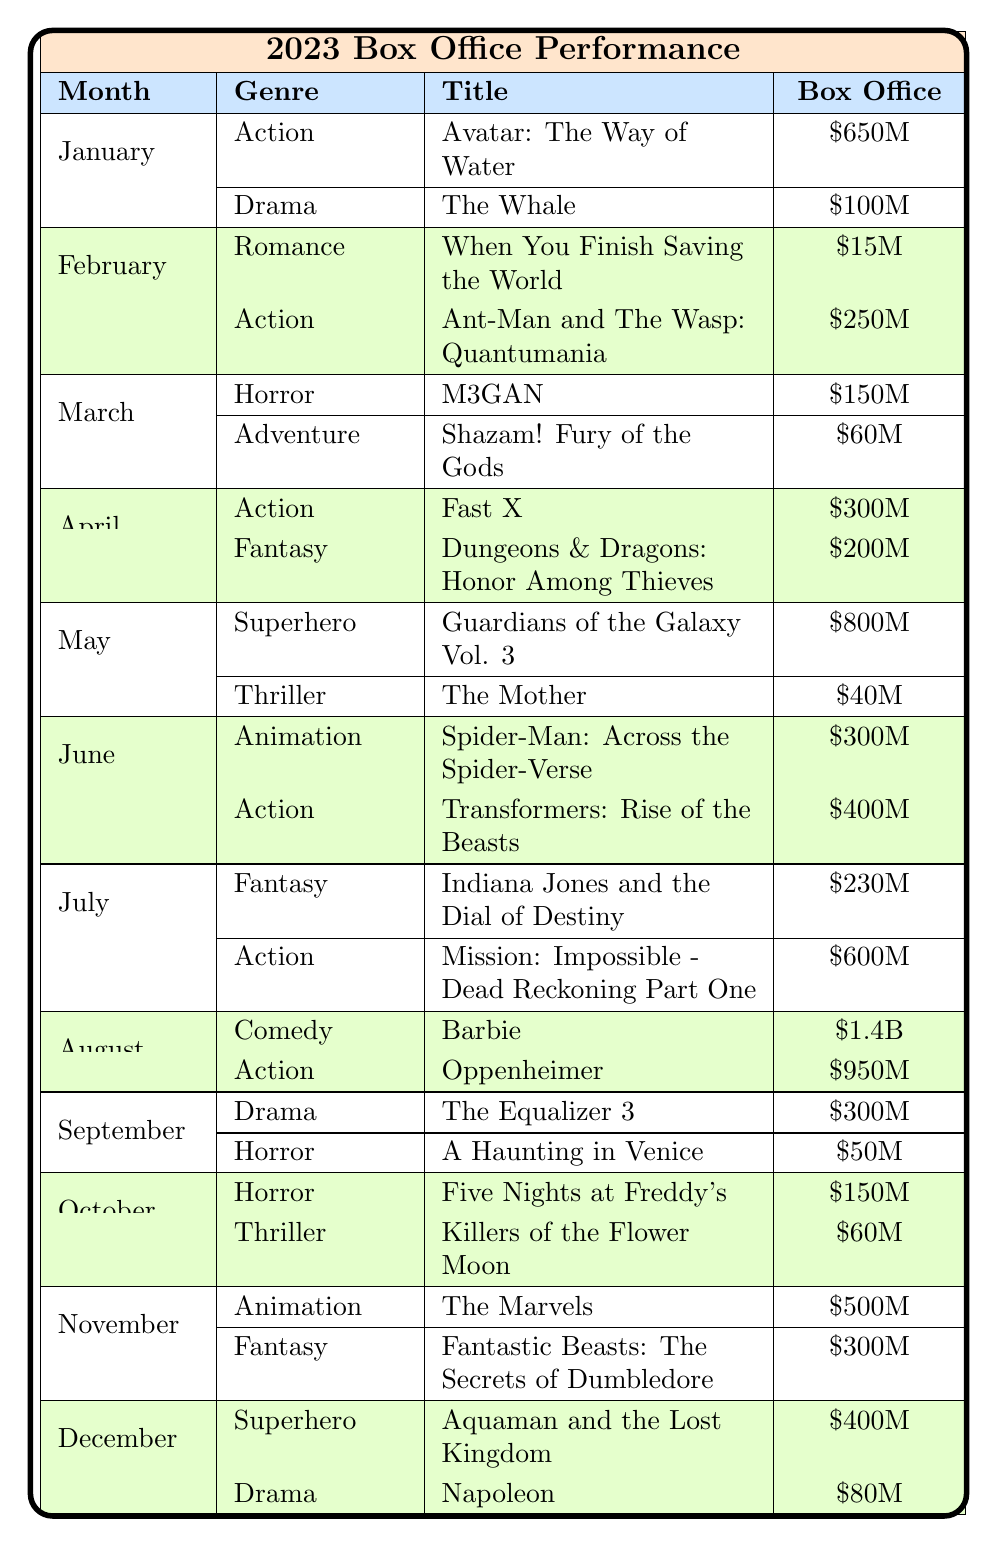What's the total box office for March? In March, the box office for M3GAN is 150 million and for Shazam! Fury of the Gods is 60 million. Adding these together gives 150 + 60 = 210 million.
Answer: 210 million Which film had the highest box office in August? In August, the film with the highest box office is Barbie, which earned 1.4 billion.
Answer: Barbie How many Action films exceeded 500 million at the box office? The Action films are Avatar: The Way of Water (650 million), Ant-Man and The Wasp: Quantumania (250 million), Fast X (300 million), Transformers: Rise of the Beasts (400 million), Mission: Impossible - Dead Reckoning Part One (600 million), Oppenheimer (950 million). The only films exceeding 500 million are Avatar: The Way of Water (650 million) and Oppenheimer (950 million), totaling 2 films.
Answer: 2 films Was there any Drama film released in December? The table lists Napoleon as a Drama film released in December, confirming that there is a Drama film for that month.
Answer: Yes What is the total box office revenue from Fantasy films in 2023? The Fantasy films are Dungeons & Dragons: Honor Among Thieves (200 million, released in April), Indiana Jones and the Dial of Destiny (230 million, released in July), and Fantastic Beasts: The Secrets of Dumbledore (300 million, released in November). Adding these gives 200 + 230 + 300 = 730 million.
Answer: 730 million Which month had the film with the lowest box office? In February, When You Finish Saving the World, a Romance film, earned 15 million, which is the lowest total for any film listed across all months.
Answer: February How much did Animation films make in June? In June, there is one Animation film listed, Spider-Man: Across the Spider-Verse, which made 300 million in box office revenue.
Answer: 300 million What is the difference in box office earnings between the highest and lowest Action films? The highest Action film is Barbie with 1.4 billion and the lowest Action film is Ant-Man and The Wasp: Quantumania with 250 million. The difference is 1400 - 250 = 1150 million.
Answer: 1150 million 